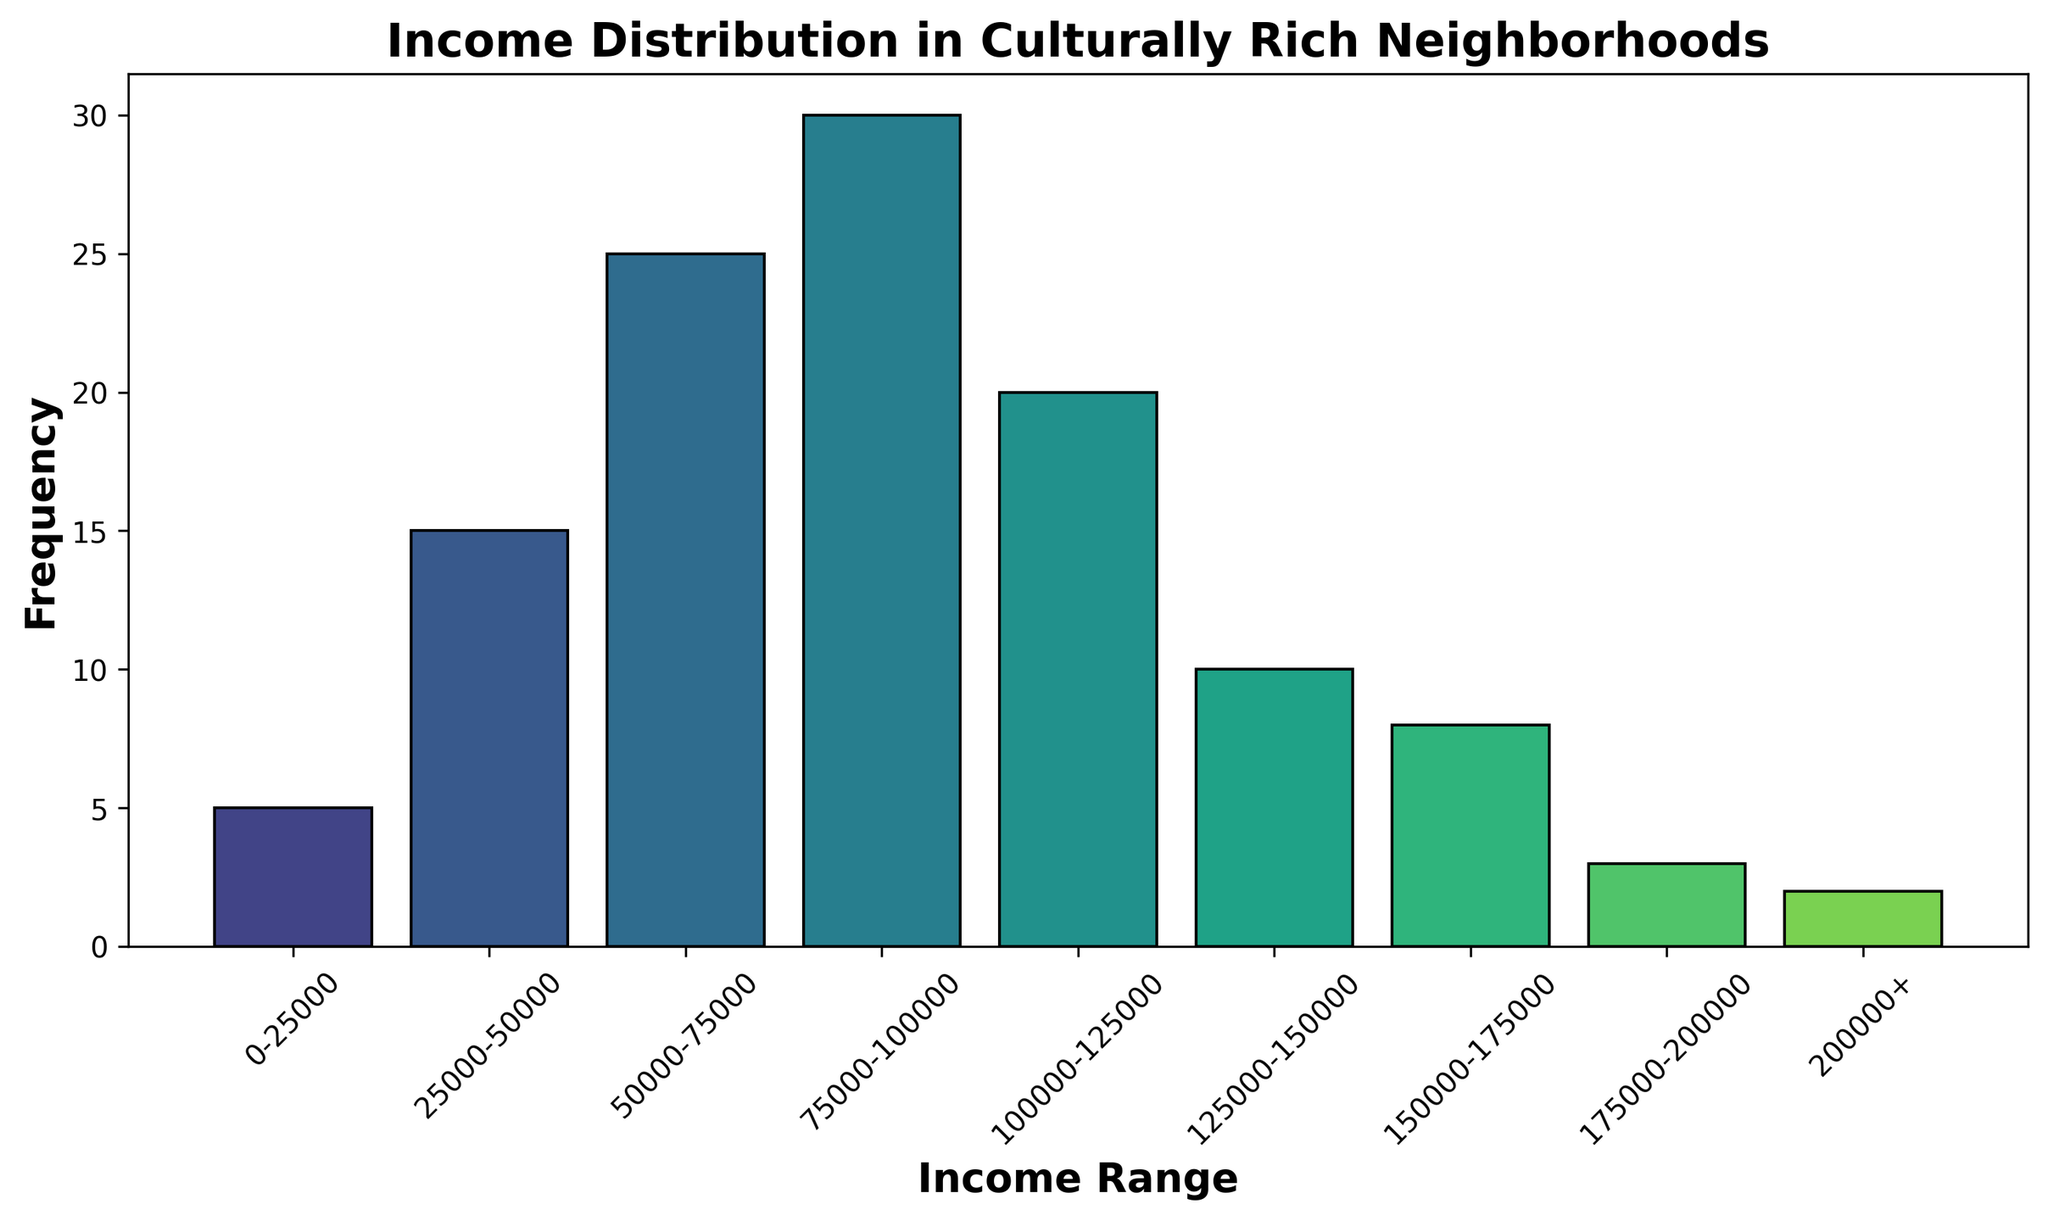What is the income range with the highest frequency? The income range with the tallest bar in the histogram represents the highest frequency. Here, the range "75000-100000" has the tallest bar.
Answer: 75000-100000 Which income range has a frequency of 2? By inspecting the histogram, the bar representing the income range with a frequency of 2 is "200000+".
Answer: 200000+ What is the total frequency represented in the histogram? To find the total frequency, sum all the frequencies in the histogram: 5 + 15 + 25 + 30 + 20 + 10 + 8 + 3 + 2 = 118.
Answer: 118 How many income ranges have a frequency of 10 or more? Count the bars with frequencies of 10 or more: "25000-50000" (15), "50000-75000" (25), "75000-100000" (30), "100000-125000" (20), and "125000-150000" (10). That's 5 ranges.
Answer: 5 What is the combined frequency of the two lowest income ranges? Add the frequencies of the two lowest income ranges: 5 (0-25000) + 15 (25000-50000) = 20.
Answer: 20 Which income range has a higher frequency: 50000-75000 or 125000-150000? Comparing the heights of the bars, the "50000-75000" range (25) has a higher frequency than "125000-150000" (10).
Answer: 50000-75000 What is the average frequency of the income ranges with frequencies above 20? The ranges with frequencies above 20 are "50000-75000" (25) and "75000-100000" (30). The average is (25 + 30) / 2 = 27.5.
Answer: 27.5 How does the frequency of the "150000-175000" range compare to that of the "175000-200000" range? The frequency for "150000-175000" is 8, whereas for "175000-200000" it is 3. Therefore, "150000-175000" has a higher frequency.
Answer: 150000-175000 What's the most frequent income range below 100000? Inspecting the bars below 100000, the "75000-100000" range is the most frequent with a frequency of 30.
Answer: 75000-100000 